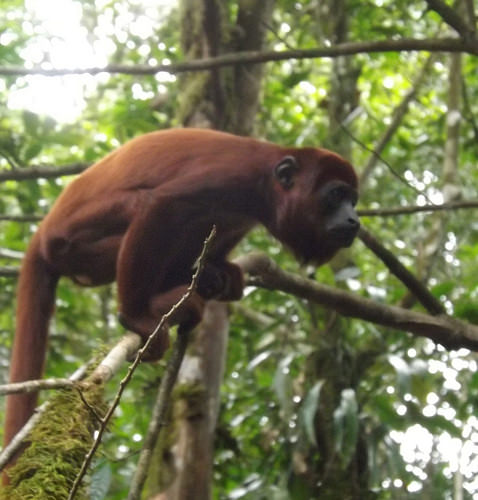<image>
Can you confirm if the monkey is on the branch? Yes. Looking at the image, I can see the monkey is positioned on top of the branch, with the branch providing support. Is there a monkey in the branch? Yes. The monkey is contained within or inside the branch, showing a containment relationship. 